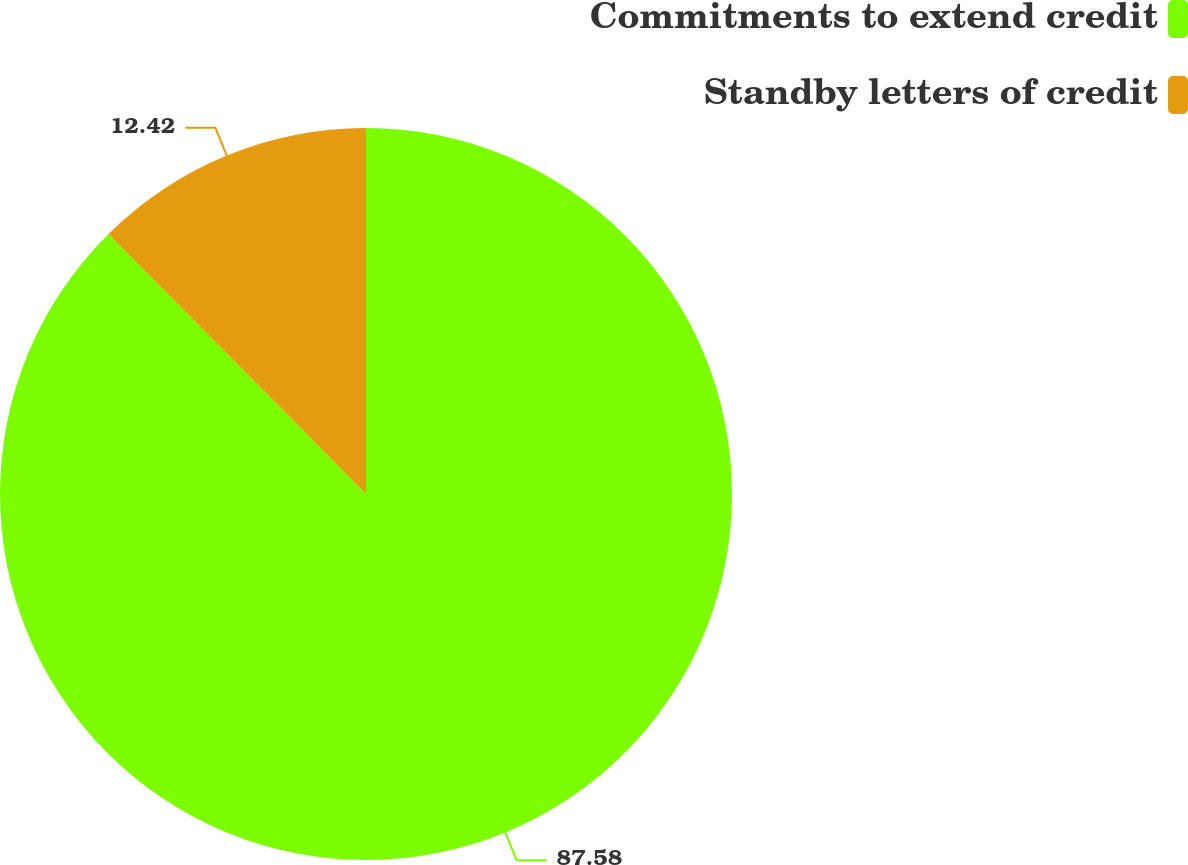Convert chart. <chart><loc_0><loc_0><loc_500><loc_500><pie_chart><fcel>Commitments to extend credit<fcel>Standby letters of credit<nl><fcel>87.58%<fcel>12.42%<nl></chart> 